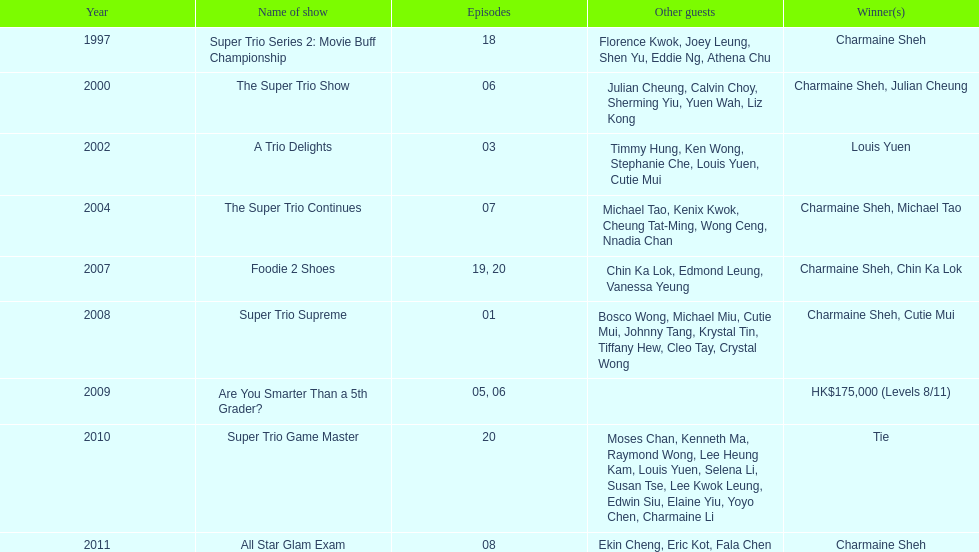What was the total number of trio series shows were charmaine sheh on? 6. 